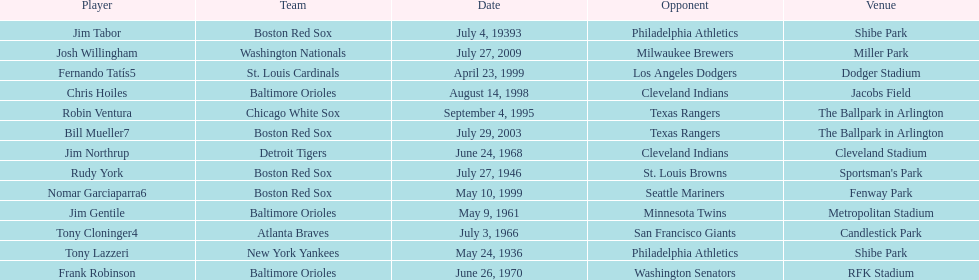What venue did detroit play cleveland in? Cleveland Stadium. Who was the player? Jim Northrup. What date did they play? June 24, 1968. 